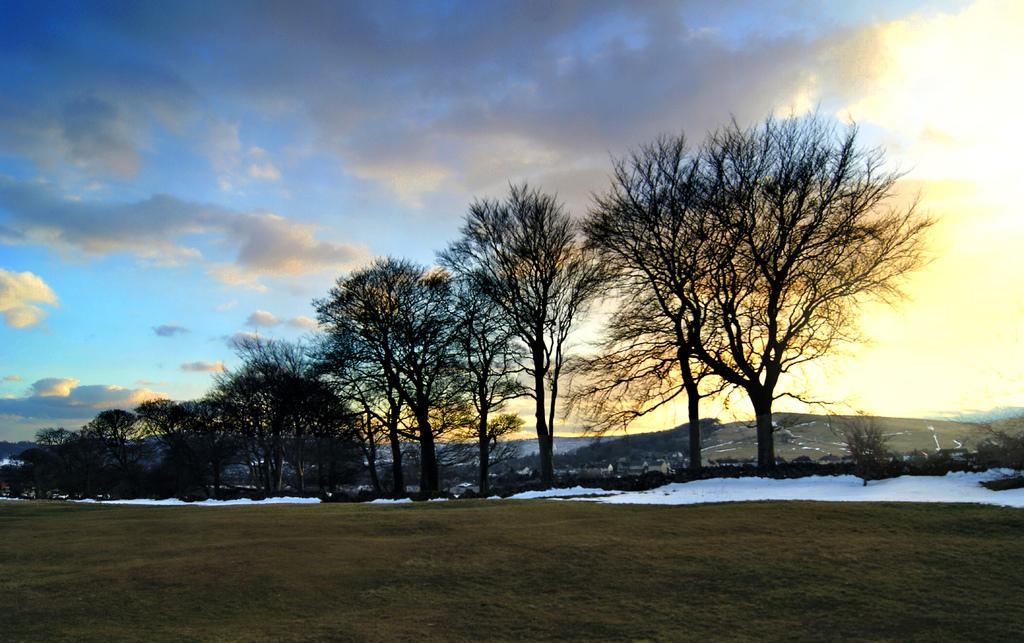What type of vegetation can be seen in the middle of the ground in the image? There are dry trees in the middle of the ground in the image. What can be seen on the ground in the image? The ground is visible in the image, and there is snow on it. What is visible in the sky in the image? The sky is visible in the image, and clouds are present in it. Can you find the receipt for the can of loss in the image? There is no receipt, can, or loss present in the image. 